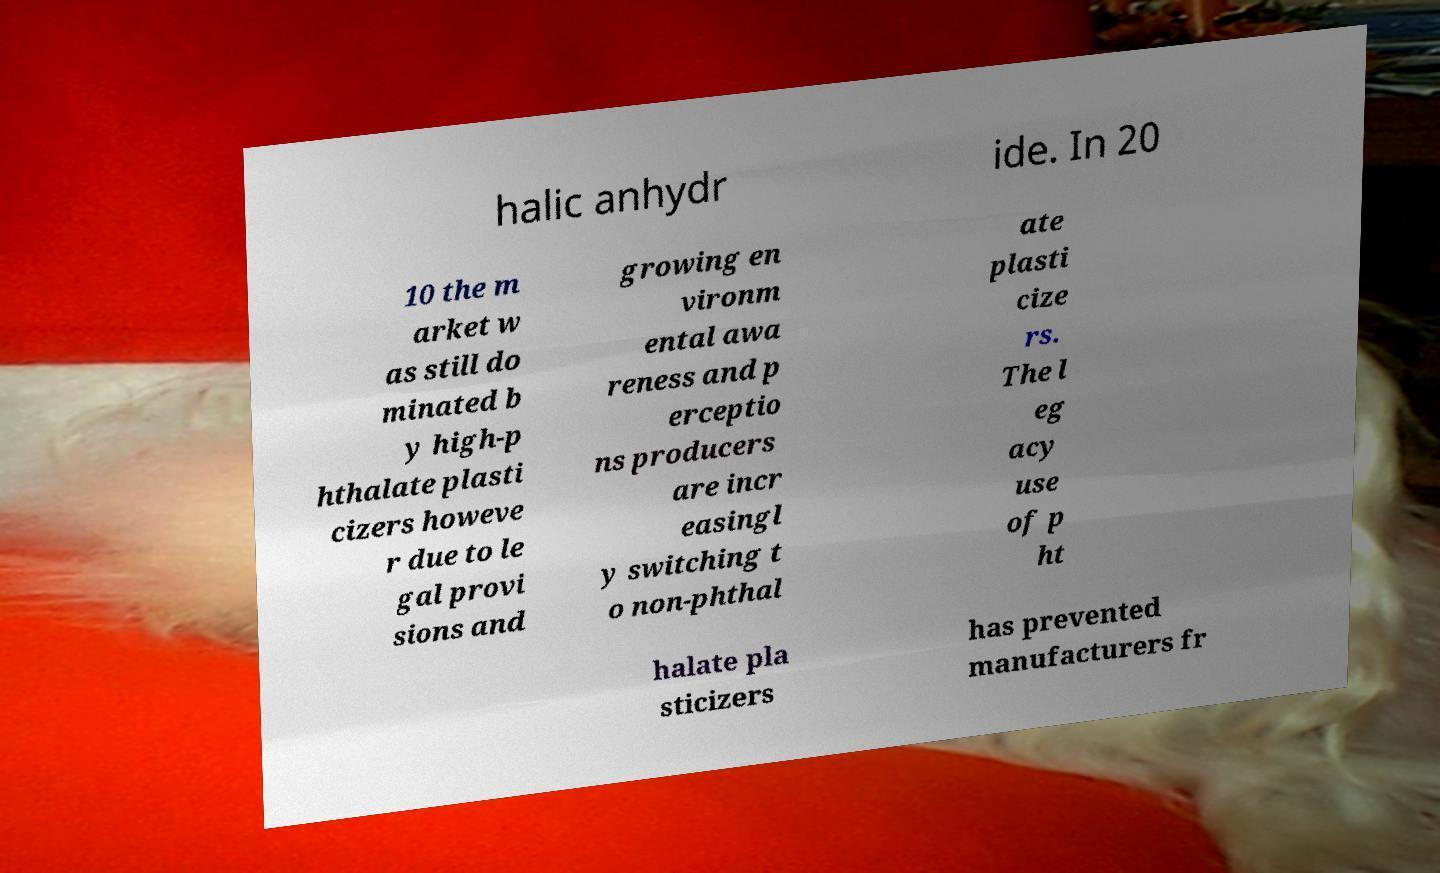There's text embedded in this image that I need extracted. Can you transcribe it verbatim? halic anhydr ide. In 20 10 the m arket w as still do minated b y high-p hthalate plasti cizers howeve r due to le gal provi sions and growing en vironm ental awa reness and p erceptio ns producers are incr easingl y switching t o non-phthal ate plasti cize rs. The l eg acy use of p ht halate pla sticizers has prevented manufacturers fr 